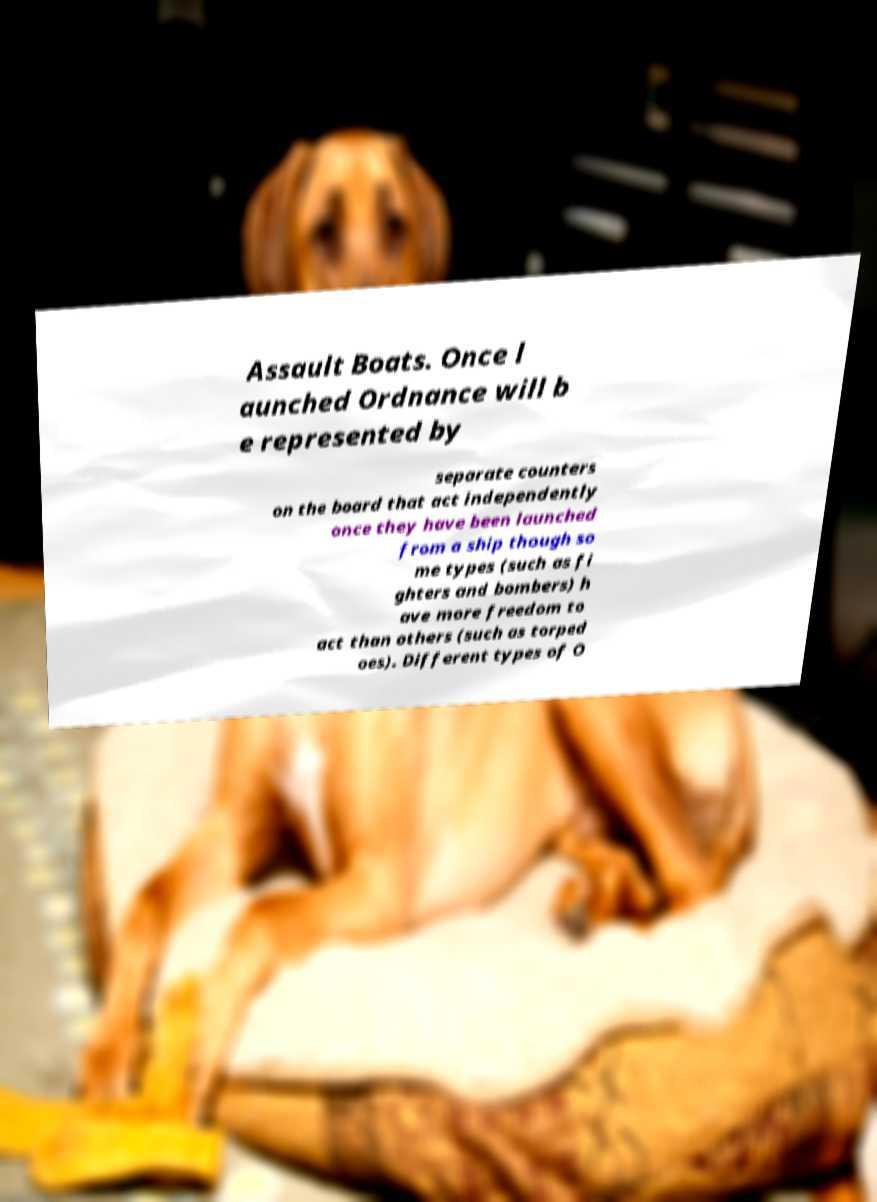Can you read and provide the text displayed in the image?This photo seems to have some interesting text. Can you extract and type it out for me? Assault Boats. Once l aunched Ordnance will b e represented by separate counters on the board that act independently once they have been launched from a ship though so me types (such as fi ghters and bombers) h ave more freedom to act than others (such as torped oes). Different types of O 